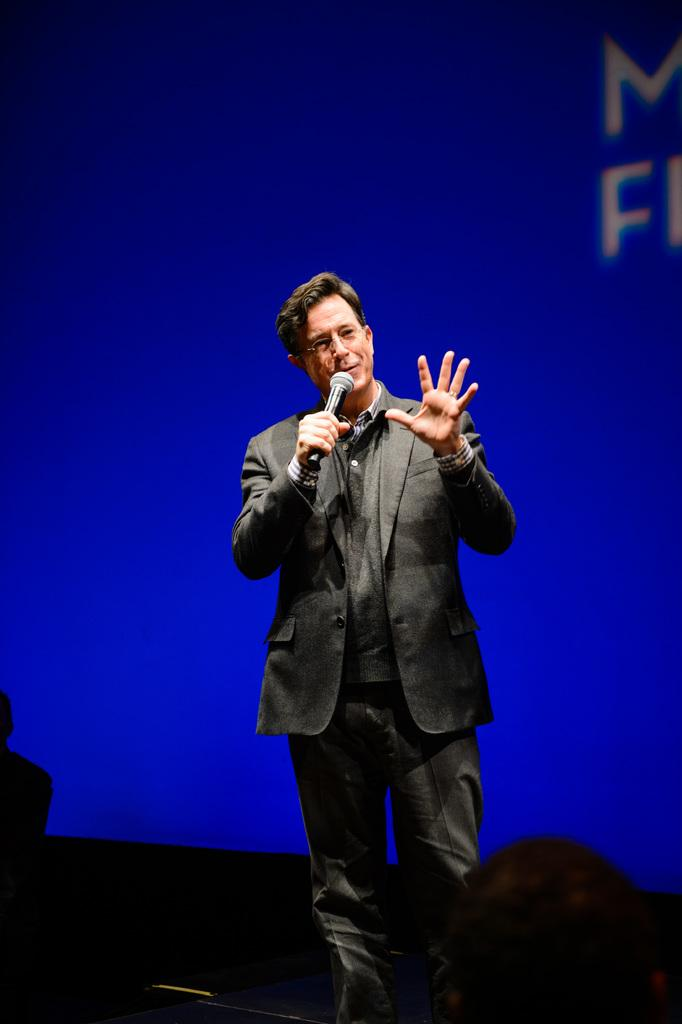Who is present in the image? There is a man in the image. What is the man holding in his hand? The man is holding a microphone (mike) in his hand. What can be seen in the background of the image? There is a banner in the background of the image. What type of powder is being used by the man in the image? There is no powder visible in the image; the man is holding a microphone. 